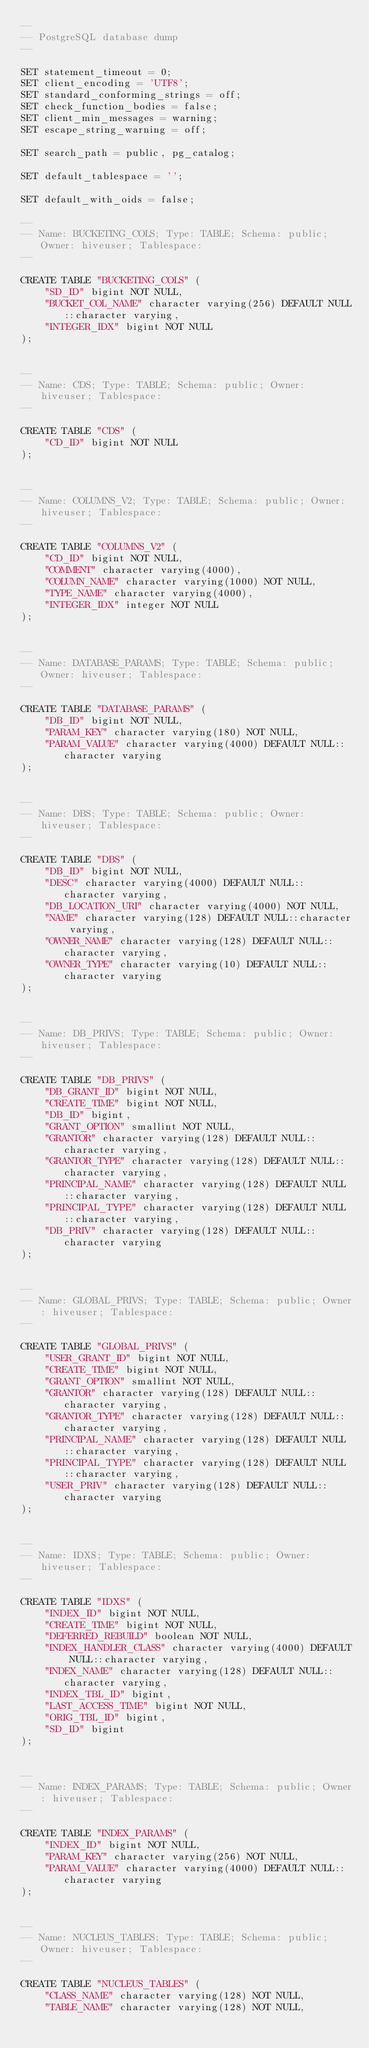Convert code to text. <code><loc_0><loc_0><loc_500><loc_500><_SQL_>--
-- PostgreSQL database dump
--

SET statement_timeout = 0;
SET client_encoding = 'UTF8';
SET standard_conforming_strings = off;
SET check_function_bodies = false;
SET client_min_messages = warning;
SET escape_string_warning = off;

SET search_path = public, pg_catalog;

SET default_tablespace = '';

SET default_with_oids = false;

--
-- Name: BUCKETING_COLS; Type: TABLE; Schema: public; Owner: hiveuser; Tablespace:
--

CREATE TABLE "BUCKETING_COLS" (
    "SD_ID" bigint NOT NULL,
    "BUCKET_COL_NAME" character varying(256) DEFAULT NULL::character varying,
    "INTEGER_IDX" bigint NOT NULL
);


--
-- Name: CDS; Type: TABLE; Schema: public; Owner: hiveuser; Tablespace:
--

CREATE TABLE "CDS" (
    "CD_ID" bigint NOT NULL
);


--
-- Name: COLUMNS_V2; Type: TABLE; Schema: public; Owner: hiveuser; Tablespace:
--

CREATE TABLE "COLUMNS_V2" (
    "CD_ID" bigint NOT NULL,
    "COMMENT" character varying(4000),
    "COLUMN_NAME" character varying(1000) NOT NULL,
    "TYPE_NAME" character varying(4000),
    "INTEGER_IDX" integer NOT NULL
);


--
-- Name: DATABASE_PARAMS; Type: TABLE; Schema: public; Owner: hiveuser; Tablespace:
--

CREATE TABLE "DATABASE_PARAMS" (
    "DB_ID" bigint NOT NULL,
    "PARAM_KEY" character varying(180) NOT NULL,
    "PARAM_VALUE" character varying(4000) DEFAULT NULL::character varying
);


--
-- Name: DBS; Type: TABLE; Schema: public; Owner: hiveuser; Tablespace:
--

CREATE TABLE "DBS" (
    "DB_ID" bigint NOT NULL,
    "DESC" character varying(4000) DEFAULT NULL::character varying,
    "DB_LOCATION_URI" character varying(4000) NOT NULL,
    "NAME" character varying(128) DEFAULT NULL::character varying,
    "OWNER_NAME" character varying(128) DEFAULT NULL::character varying,
    "OWNER_TYPE" character varying(10) DEFAULT NULL::character varying
);


--
-- Name: DB_PRIVS; Type: TABLE; Schema: public; Owner: hiveuser; Tablespace:
--

CREATE TABLE "DB_PRIVS" (
    "DB_GRANT_ID" bigint NOT NULL,
    "CREATE_TIME" bigint NOT NULL,
    "DB_ID" bigint,
    "GRANT_OPTION" smallint NOT NULL,
    "GRANTOR" character varying(128) DEFAULT NULL::character varying,
    "GRANTOR_TYPE" character varying(128) DEFAULT NULL::character varying,
    "PRINCIPAL_NAME" character varying(128) DEFAULT NULL::character varying,
    "PRINCIPAL_TYPE" character varying(128) DEFAULT NULL::character varying,
    "DB_PRIV" character varying(128) DEFAULT NULL::character varying
);


--
-- Name: GLOBAL_PRIVS; Type: TABLE; Schema: public; Owner: hiveuser; Tablespace:
--

CREATE TABLE "GLOBAL_PRIVS" (
    "USER_GRANT_ID" bigint NOT NULL,
    "CREATE_TIME" bigint NOT NULL,
    "GRANT_OPTION" smallint NOT NULL,
    "GRANTOR" character varying(128) DEFAULT NULL::character varying,
    "GRANTOR_TYPE" character varying(128) DEFAULT NULL::character varying,
    "PRINCIPAL_NAME" character varying(128) DEFAULT NULL::character varying,
    "PRINCIPAL_TYPE" character varying(128) DEFAULT NULL::character varying,
    "USER_PRIV" character varying(128) DEFAULT NULL::character varying
);


--
-- Name: IDXS; Type: TABLE; Schema: public; Owner: hiveuser; Tablespace:
--

CREATE TABLE "IDXS" (
    "INDEX_ID" bigint NOT NULL,
    "CREATE_TIME" bigint NOT NULL,
    "DEFERRED_REBUILD" boolean NOT NULL,
    "INDEX_HANDLER_CLASS" character varying(4000) DEFAULT NULL::character varying,
    "INDEX_NAME" character varying(128) DEFAULT NULL::character varying,
    "INDEX_TBL_ID" bigint,
    "LAST_ACCESS_TIME" bigint NOT NULL,
    "ORIG_TBL_ID" bigint,
    "SD_ID" bigint
);


--
-- Name: INDEX_PARAMS; Type: TABLE; Schema: public; Owner: hiveuser; Tablespace:
--

CREATE TABLE "INDEX_PARAMS" (
    "INDEX_ID" bigint NOT NULL,
    "PARAM_KEY" character varying(256) NOT NULL,
    "PARAM_VALUE" character varying(4000) DEFAULT NULL::character varying
);


--
-- Name: NUCLEUS_TABLES; Type: TABLE; Schema: public; Owner: hiveuser; Tablespace:
--

CREATE TABLE "NUCLEUS_TABLES" (
    "CLASS_NAME" character varying(128) NOT NULL,
    "TABLE_NAME" character varying(128) NOT NULL,</code> 